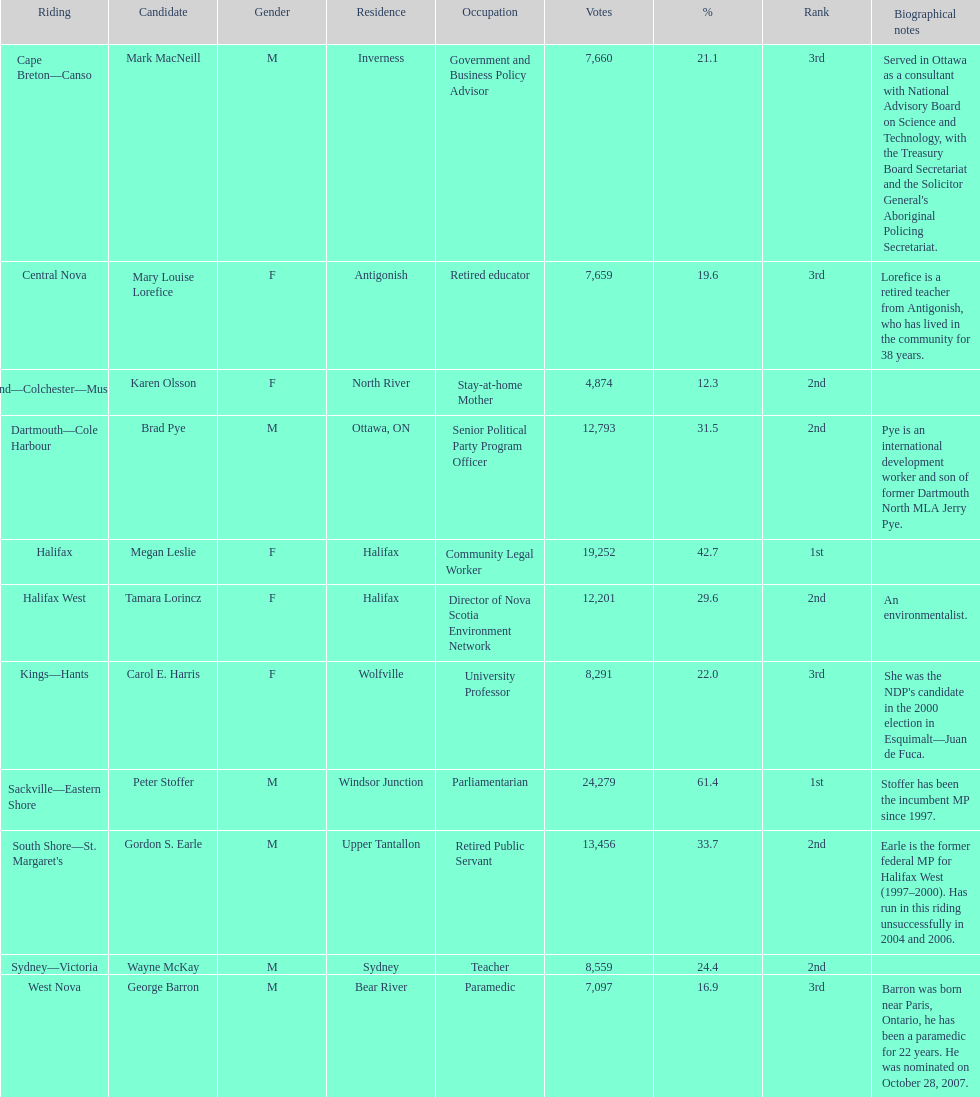Can you provide the count of halifax-based candidates? 2. 